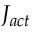<formula> <loc_0><loc_0><loc_500><loc_500>J _ { a c t }</formula> 